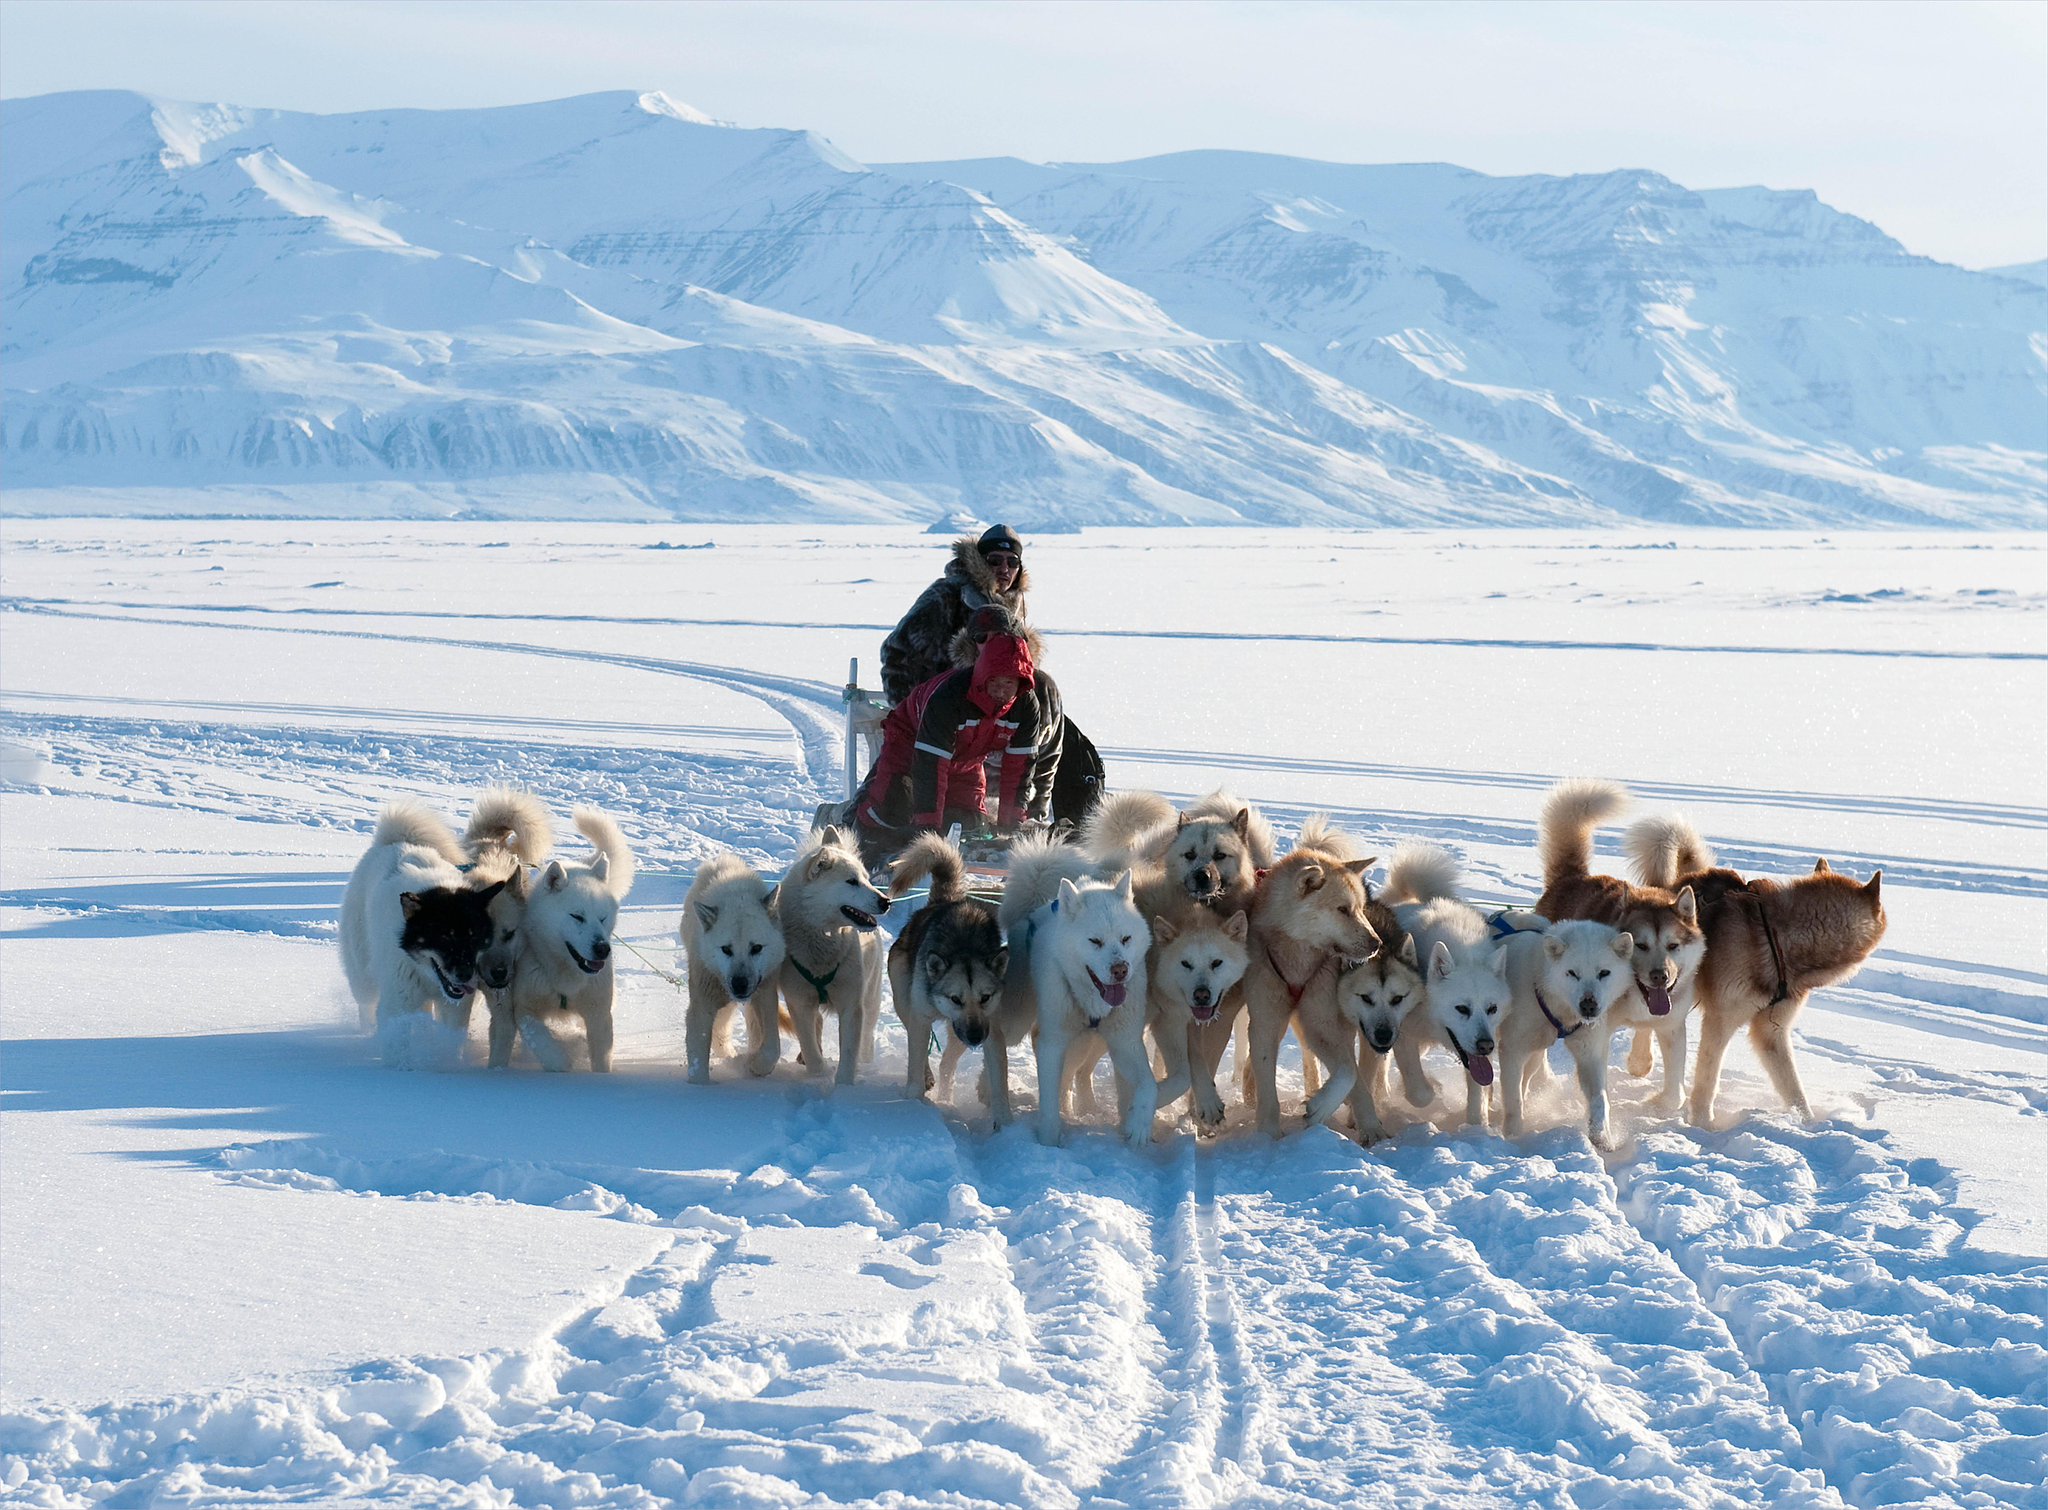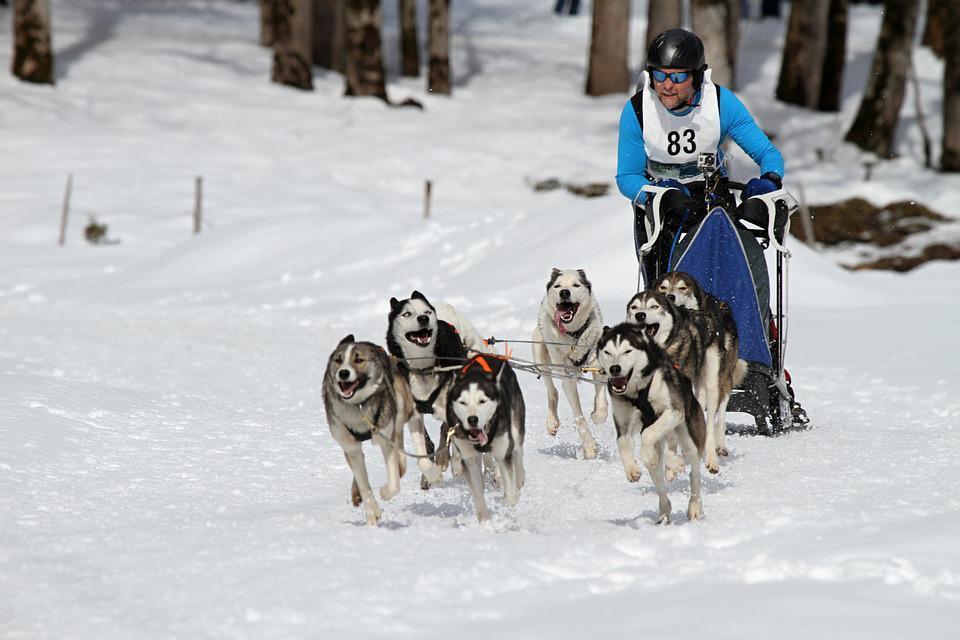The first image is the image on the left, the second image is the image on the right. Given the left and right images, does the statement "There are 3 sled dogs pulling a sled" hold true? Answer yes or no. No. 